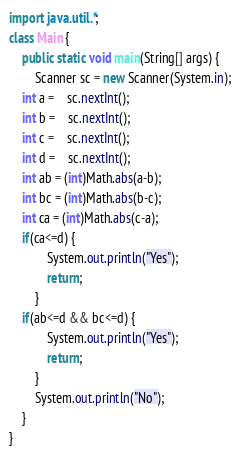Convert code to text. <code><loc_0><loc_0><loc_500><loc_500><_Java_>import java.util.*;
class Main {
    public static void main(String[] args) {
        Scanner sc = new Scanner(System.in);
	int a =	sc.nextInt();
	int b =	sc.nextInt();
	int c =	sc.nextInt();
	int d =	sc.nextInt();
	int ab = (int)Math.abs(a-b);
	int bc = (int)Math.abs(b-c);
	int ca = (int)Math.abs(c-a);
	if(ca<=d) {
            System.out.println("Yes");
            return;
        }
	if(ab<=d && bc<=d) {
            System.out.println("Yes");
            return;
        }
        System.out.println("No");
    }
}</code> 